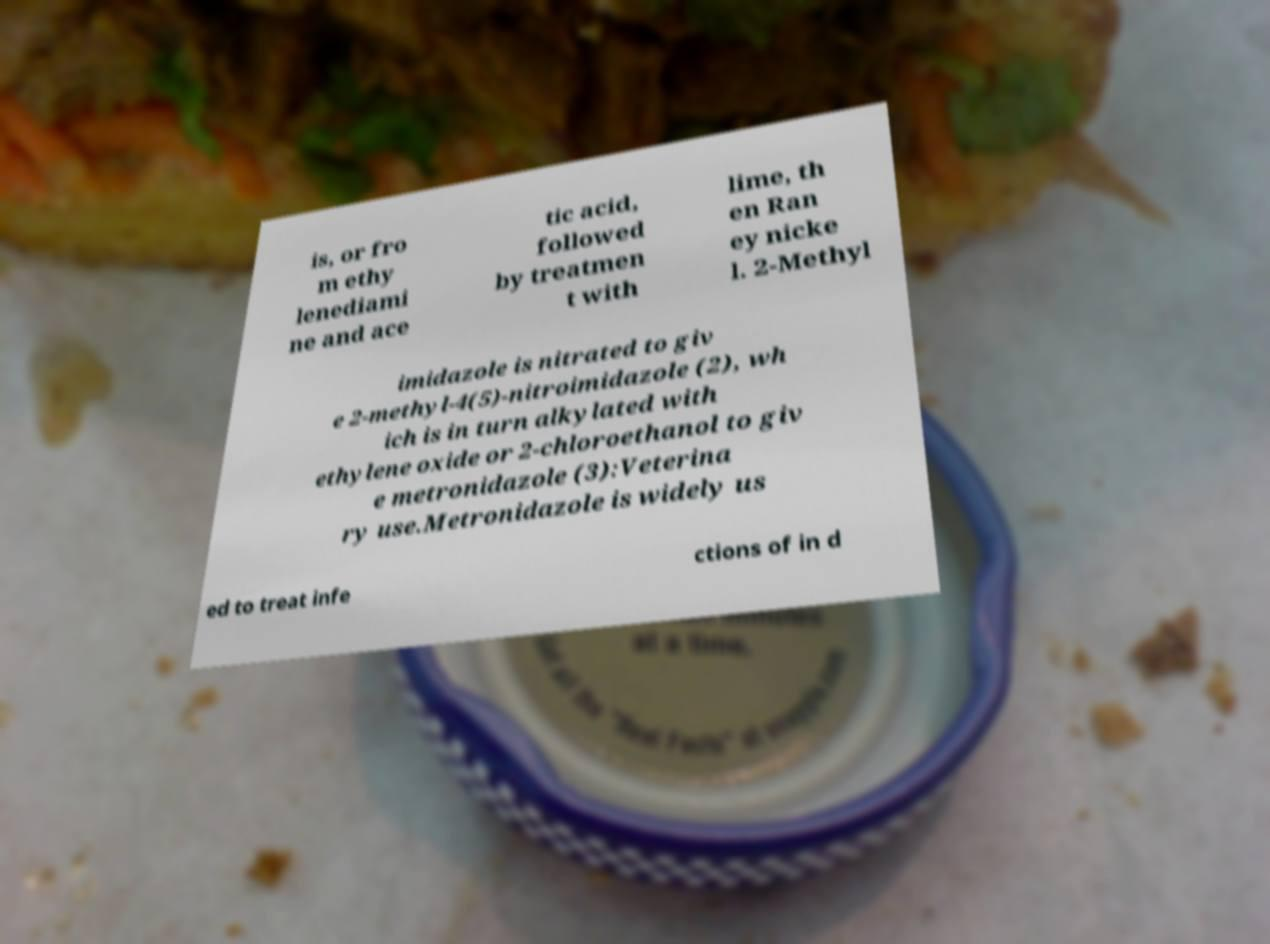Can you accurately transcribe the text from the provided image for me? is, or fro m ethy lenediami ne and ace tic acid, followed by treatmen t with lime, th en Ran ey nicke l. 2-Methyl imidazole is nitrated to giv e 2-methyl-4(5)-nitroimidazole (2), wh ich is in turn alkylated with ethylene oxide or 2-chloroethanol to giv e metronidazole (3):Veterina ry use.Metronidazole is widely us ed to treat infe ctions of in d 